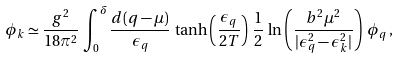<formula> <loc_0><loc_0><loc_500><loc_500>\phi _ { k } \simeq \frac { g ^ { 2 } } { 1 8 \pi ^ { 2 } } \, \int ^ { \delta } _ { 0 } \frac { d ( q - \mu ) } { \epsilon _ { q } } \, \tanh \left ( \frac { \epsilon _ { q } } { 2 T } \right ) \, \frac { 1 } { 2 } \, \ln \left ( \frac { b ^ { 2 } \mu ^ { 2 } } { | \epsilon _ { q } ^ { 2 } - \epsilon _ { k } ^ { 2 } | } \right ) \, \phi _ { q } \, ,</formula> 